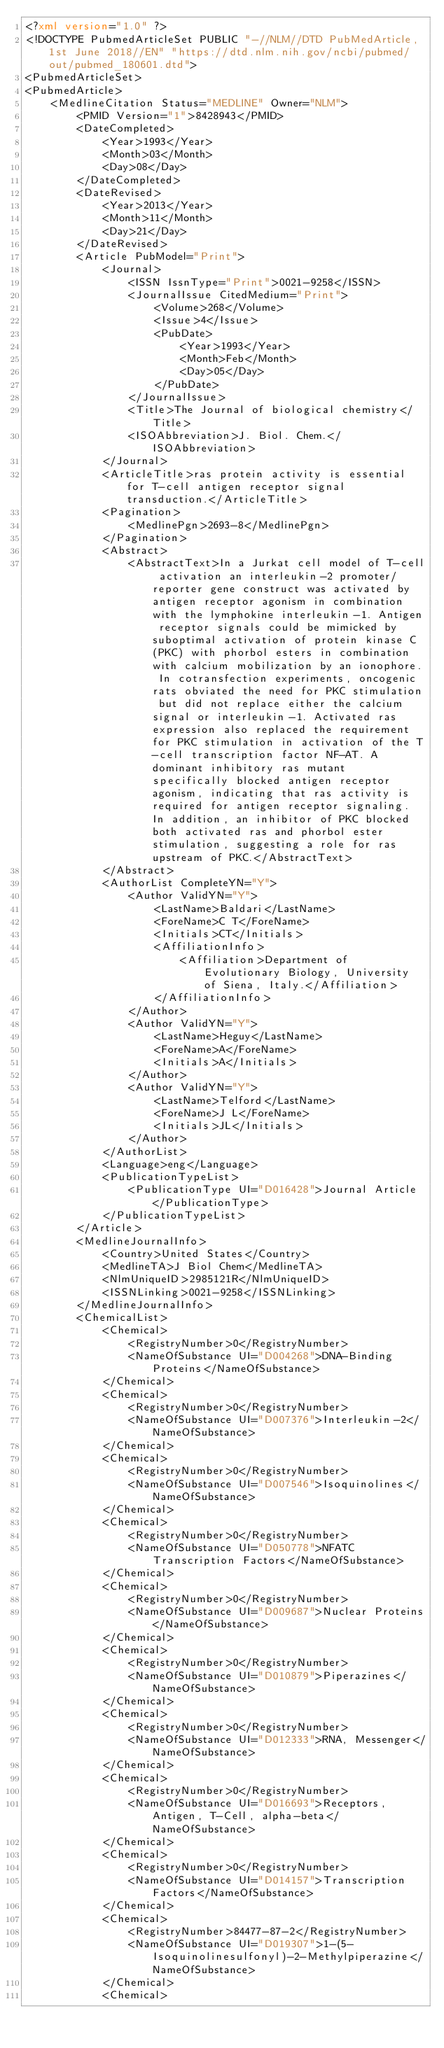<code> <loc_0><loc_0><loc_500><loc_500><_XML_><?xml version="1.0" ?>
<!DOCTYPE PubmedArticleSet PUBLIC "-//NLM//DTD PubMedArticle, 1st June 2018//EN" "https://dtd.nlm.nih.gov/ncbi/pubmed/out/pubmed_180601.dtd">
<PubmedArticleSet>
<PubmedArticle>
    <MedlineCitation Status="MEDLINE" Owner="NLM">
        <PMID Version="1">8428943</PMID>
        <DateCompleted>
            <Year>1993</Year>
            <Month>03</Month>
            <Day>08</Day>
        </DateCompleted>
        <DateRevised>
            <Year>2013</Year>
            <Month>11</Month>
            <Day>21</Day>
        </DateRevised>
        <Article PubModel="Print">
            <Journal>
                <ISSN IssnType="Print">0021-9258</ISSN>
                <JournalIssue CitedMedium="Print">
                    <Volume>268</Volume>
                    <Issue>4</Issue>
                    <PubDate>
                        <Year>1993</Year>
                        <Month>Feb</Month>
                        <Day>05</Day>
                    </PubDate>
                </JournalIssue>
                <Title>The Journal of biological chemistry</Title>
                <ISOAbbreviation>J. Biol. Chem.</ISOAbbreviation>
            </Journal>
            <ArticleTitle>ras protein activity is essential for T-cell antigen receptor signal transduction.</ArticleTitle>
            <Pagination>
                <MedlinePgn>2693-8</MedlinePgn>
            </Pagination>
            <Abstract>
                <AbstractText>In a Jurkat cell model of T-cell activation an interleukin-2 promoter/reporter gene construct was activated by antigen receptor agonism in combination with the lymphokine interleukin-1. Antigen receptor signals could be mimicked by suboptimal activation of protein kinase C (PKC) with phorbol esters in combination with calcium mobilization by an ionophore. In cotransfection experiments, oncogenic rats obviated the need for PKC stimulation but did not replace either the calcium signal or interleukin-1. Activated ras expression also replaced the requirement for PKC stimulation in activation of the T-cell transcription factor NF-AT. A dominant inhibitory ras mutant specifically blocked antigen receptor agonism, indicating that ras activity is required for antigen receptor signaling. In addition, an inhibitor of PKC blocked both activated ras and phorbol ester stimulation, suggesting a role for ras upstream of PKC.</AbstractText>
            </Abstract>
            <AuthorList CompleteYN="Y">
                <Author ValidYN="Y">
                    <LastName>Baldari</LastName>
                    <ForeName>C T</ForeName>
                    <Initials>CT</Initials>
                    <AffiliationInfo>
                        <Affiliation>Department of Evolutionary Biology, University of Siena, Italy.</Affiliation>
                    </AffiliationInfo>
                </Author>
                <Author ValidYN="Y">
                    <LastName>Heguy</LastName>
                    <ForeName>A</ForeName>
                    <Initials>A</Initials>
                </Author>
                <Author ValidYN="Y">
                    <LastName>Telford</LastName>
                    <ForeName>J L</ForeName>
                    <Initials>JL</Initials>
                </Author>
            </AuthorList>
            <Language>eng</Language>
            <PublicationTypeList>
                <PublicationType UI="D016428">Journal Article</PublicationType>
            </PublicationTypeList>
        </Article>
        <MedlineJournalInfo>
            <Country>United States</Country>
            <MedlineTA>J Biol Chem</MedlineTA>
            <NlmUniqueID>2985121R</NlmUniqueID>
            <ISSNLinking>0021-9258</ISSNLinking>
        </MedlineJournalInfo>
        <ChemicalList>
            <Chemical>
                <RegistryNumber>0</RegistryNumber>
                <NameOfSubstance UI="D004268">DNA-Binding Proteins</NameOfSubstance>
            </Chemical>
            <Chemical>
                <RegistryNumber>0</RegistryNumber>
                <NameOfSubstance UI="D007376">Interleukin-2</NameOfSubstance>
            </Chemical>
            <Chemical>
                <RegistryNumber>0</RegistryNumber>
                <NameOfSubstance UI="D007546">Isoquinolines</NameOfSubstance>
            </Chemical>
            <Chemical>
                <RegistryNumber>0</RegistryNumber>
                <NameOfSubstance UI="D050778">NFATC Transcription Factors</NameOfSubstance>
            </Chemical>
            <Chemical>
                <RegistryNumber>0</RegistryNumber>
                <NameOfSubstance UI="D009687">Nuclear Proteins</NameOfSubstance>
            </Chemical>
            <Chemical>
                <RegistryNumber>0</RegistryNumber>
                <NameOfSubstance UI="D010879">Piperazines</NameOfSubstance>
            </Chemical>
            <Chemical>
                <RegistryNumber>0</RegistryNumber>
                <NameOfSubstance UI="D012333">RNA, Messenger</NameOfSubstance>
            </Chemical>
            <Chemical>
                <RegistryNumber>0</RegistryNumber>
                <NameOfSubstance UI="D016693">Receptors, Antigen, T-Cell, alpha-beta</NameOfSubstance>
            </Chemical>
            <Chemical>
                <RegistryNumber>0</RegistryNumber>
                <NameOfSubstance UI="D014157">Transcription Factors</NameOfSubstance>
            </Chemical>
            <Chemical>
                <RegistryNumber>84477-87-2</RegistryNumber>
                <NameOfSubstance UI="D019307">1-(5-Isoquinolinesulfonyl)-2-Methylpiperazine</NameOfSubstance>
            </Chemical>
            <Chemical></code> 